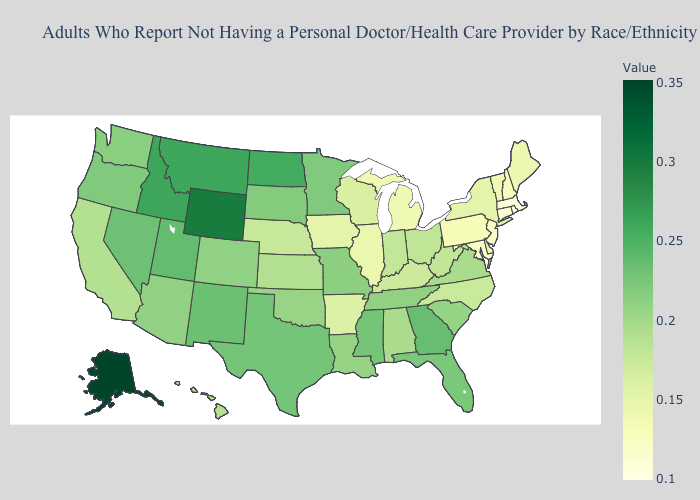Among the states that border New Hampshire , does Maine have the lowest value?
Keep it brief. No. Is the legend a continuous bar?
Give a very brief answer. Yes. Does Kansas have a lower value than New Mexico?
Keep it brief. Yes. Among the states that border Michigan , which have the highest value?
Concise answer only. Ohio. Among the states that border Alabama , does Tennessee have the lowest value?
Quick response, please. Yes. Does Michigan have the lowest value in the MidWest?
Answer briefly. Yes. 